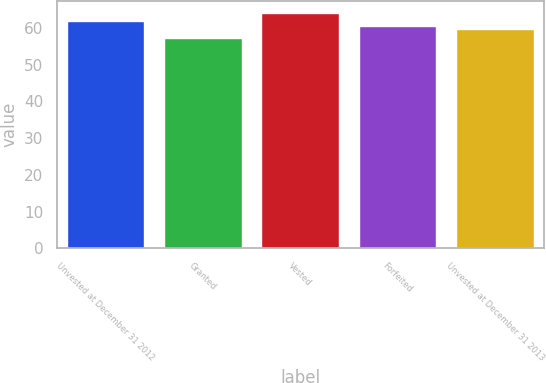Convert chart to OTSL. <chart><loc_0><loc_0><loc_500><loc_500><bar_chart><fcel>Unvested at December 31 2012<fcel>Granted<fcel>Vested<fcel>Forfeited<fcel>Unvested at December 31 2013<nl><fcel>61.75<fcel>57.27<fcel>64.13<fcel>60.45<fcel>59.76<nl></chart> 